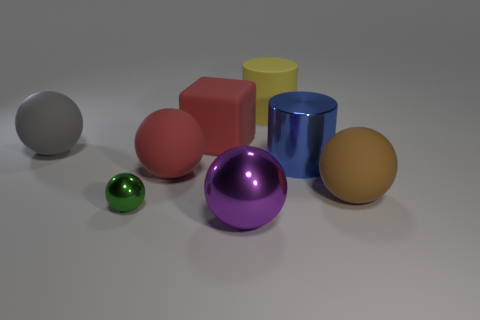Do the cylinder behind the gray rubber object and the big ball that is in front of the brown matte ball have the same color?
Provide a succinct answer. No. What is the color of the big rubber sphere that is on the left side of the large yellow object and on the right side of the gray thing?
Offer a terse response. Red. How many other things are the same shape as the large brown matte thing?
Provide a succinct answer. 4. There is a matte block that is the same size as the gray object; what color is it?
Give a very brief answer. Red. There is a matte ball that is on the right side of the shiny cylinder; what is its color?
Make the answer very short. Brown. There is a big object in front of the tiny metal sphere; is there a blue cylinder that is in front of it?
Your response must be concise. No. Do the gray rubber object and the large object that is in front of the green object have the same shape?
Provide a short and direct response. Yes. There is a matte object that is right of the large red block and behind the big red ball; how big is it?
Ensure brevity in your answer.  Large. Is there a big red cylinder made of the same material as the large block?
Offer a very short reply. No. What size is the matte object that is the same color as the large rubber block?
Ensure brevity in your answer.  Large. 